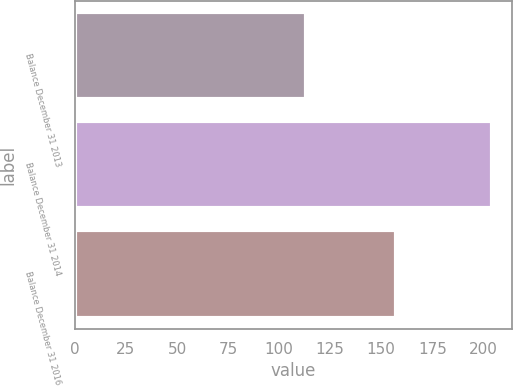Convert chart to OTSL. <chart><loc_0><loc_0><loc_500><loc_500><bar_chart><fcel>Balance December 31 2013<fcel>Balance December 31 2014<fcel>Balance December 31 2016<nl><fcel>113<fcel>204<fcel>157<nl></chart> 